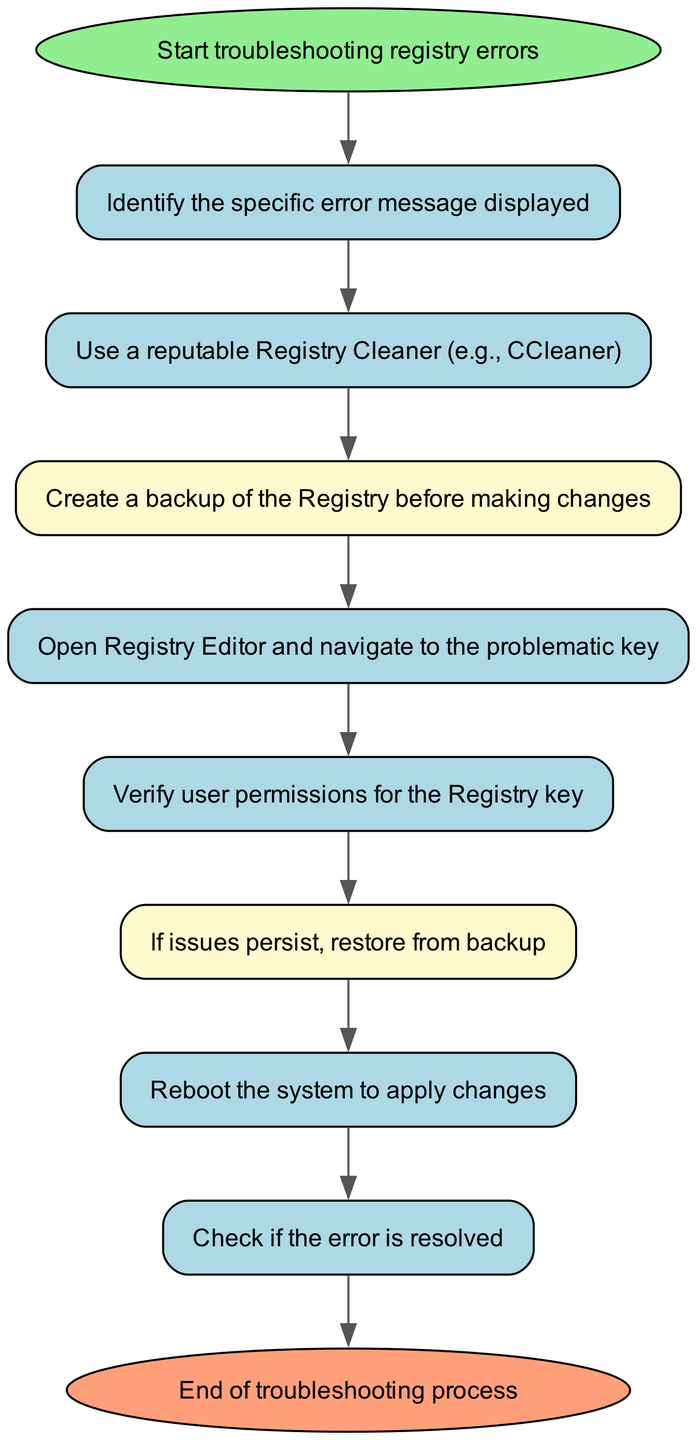What is the first step in the troubleshooting process? The first step in the flow chart is "Start troubleshooting registry errors," which indicates the beginning of the process.
Answer: Start troubleshooting registry errors How many nodes are present in the diagram? The diagram consists of five main steps, plus the start and end, totaling seven nodes: Start, Check Error Message, Run Registry Cleaner, Backup Registry, Edit Registry, Check Permissions, Restore Backup, Reboot System, Confirm Resolution, End.
Answer: Seven What action follows "Backup Registry"? After "Backup Registry," the next action is "Edit Registry," which signifies the step where the user will navigate to the problematic registry key.
Answer: Edit Registry What is the final action taken in the flow chart? The last action in the flow chart is "End of troubleshooting process," which signifies the conclusion of the troubleshooting steps.
Answer: End of troubleshooting process Before making changes to the registry, what precaution should be taken? The precaution that should be taken before making changes is "Create a backup of the Registry." This ensures that you can restore if something goes wrong.
Answer: Create a backup of the Registry If issues persist after editing the registry, what should be done? If issues continue, the step to take is "Restore from backup," which indicates reverting to a backup created earlier to fix any problems caused by changes.
Answer: Restore from backup 